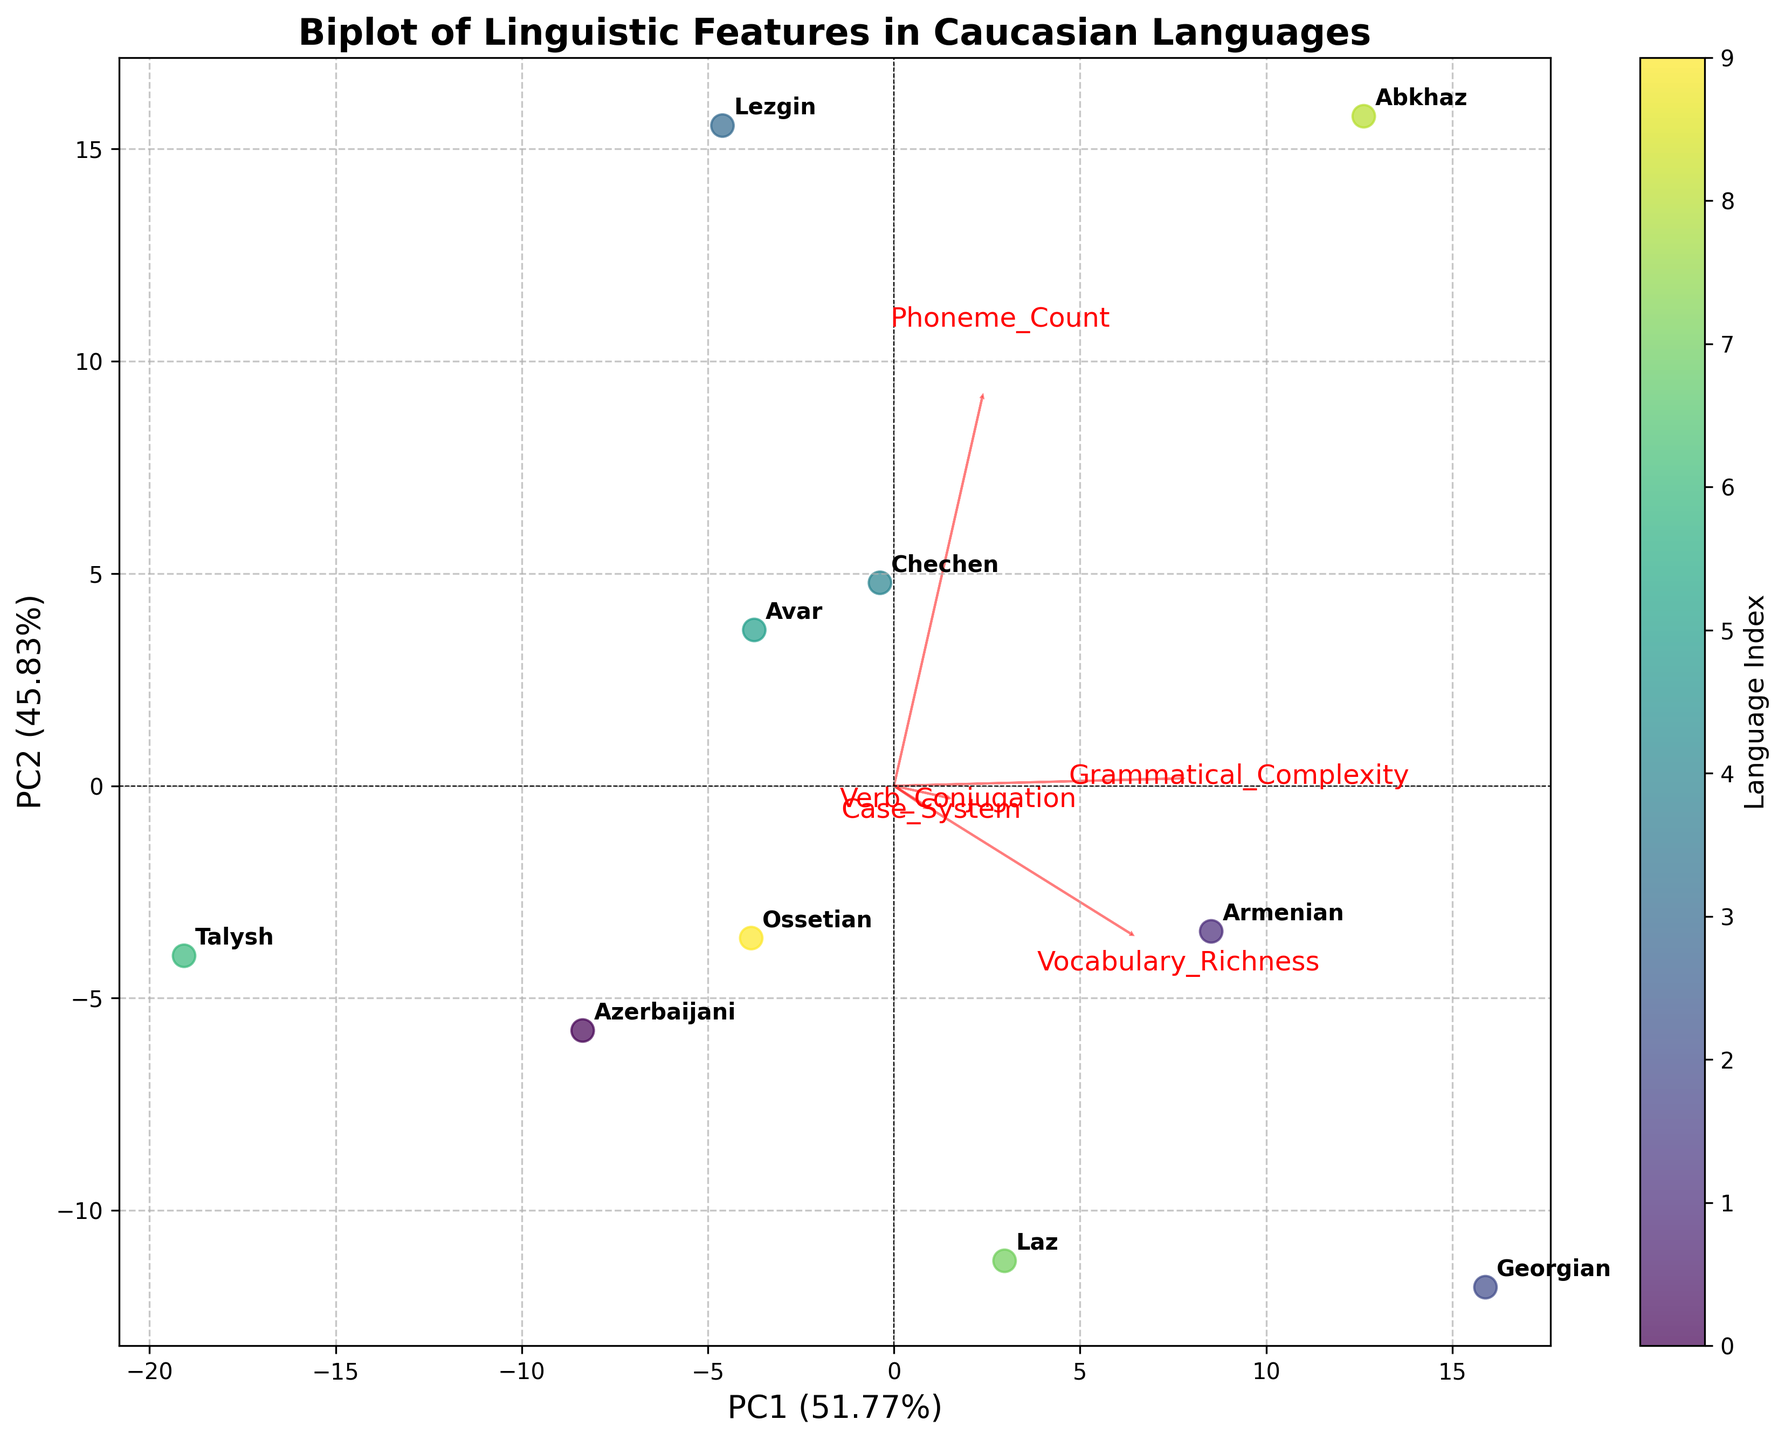What is the title of the biplot? The title of the biplot is displayed at the top of the figure. It provides an overview of what the plot represents.
Answer: Biplot of Linguistic Features in Caucasian Languages How many languages are analyzed in the biplot? By counting the number of data points or language labels in the plot, we can determine the number of languages analyzed.
Answer: 10 Which language appears farthest to the right on the biplot? The language farthest to the right on the biplot can be identified by looking at the extreme rightmost data point/language label along the PC1 axis.
Answer: Armenian Which feature has the highest loading on PC1? To determine the feature with the highest loading on PC1, examine the length and direction of the arrows along the PC1 axis. The feature with the longest arrow in the positive direction of PC1 has the highest loading.
Answer: Grammatical_Complexity Which language has the highest Vocabulary Richness based on the biplot? The biplot's PC1 and PC2 axes are influenced by the features, and languages with higher values in one feature will tend to be positioned along the direction of that feature's loading arrow. Identify the language closest to the Vocabulary_Richness arrow.
Answer: Georgian How do Georgian and Azerbaijani languages compare in terms of Grammatical Complexity? By observing the position of Georgian and Azerbaijani on the biplot relative to the Grammatical_Complexity loadings, we can compare their values. Georgian should be positioned closer to the direction of the Grammatical_Complexity arrow if it has a higher value.
Answer: Georgian has higher Grammatical Complexity than Azerbaijani Which two languages are most similar in terms of their PCA scores? This can be answered by identifying the two languages whose data points are closest to each other on the biplot, indicating similarity in their PCA scores.
Answer: Azerbaijani and Chechen What percentage of the variance is explained by PC1 and PC2? The axes labels indicate the percentage of variance explained by each principal component. Summing the percentages for PC1 and PC2 gives the total variance explained by these two components.
Answer: Around 84% Are there any languages that have a high Verb Conjugation but lower Case Systems in the biplot? Languages with high Verb Conjugation are positioned along the direction of the Verb_Conjugation arrow, while those with lower Case Systems would be positioned away from the Case_System arrow. Finding a language with these characteristics requires comparing their relative positions.
Answer: Yes, Abkhaz Which feature appears to contribute equally to PC1 and PC2? A feature that contributes equally to both PC1 and PC2 will have an arrow direction that is roughly diagonal between the PC1 and PC2 axes. By examining the directions of the feature loadings, we can determine which one fits this description.
Answer: Verb_Conjugation 